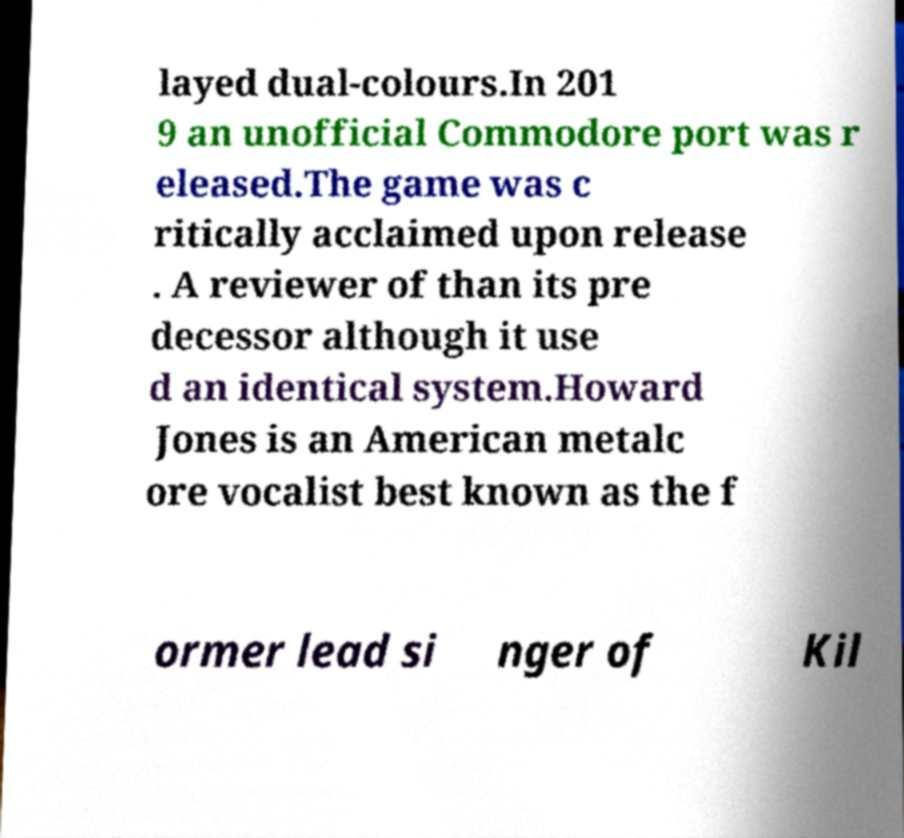Can you accurately transcribe the text from the provided image for me? layed dual-colours.In 201 9 an unofficial Commodore port was r eleased.The game was c ritically acclaimed upon release . A reviewer of than its pre decessor although it use d an identical system.Howard Jones is an American metalc ore vocalist best known as the f ormer lead si nger of Kil 